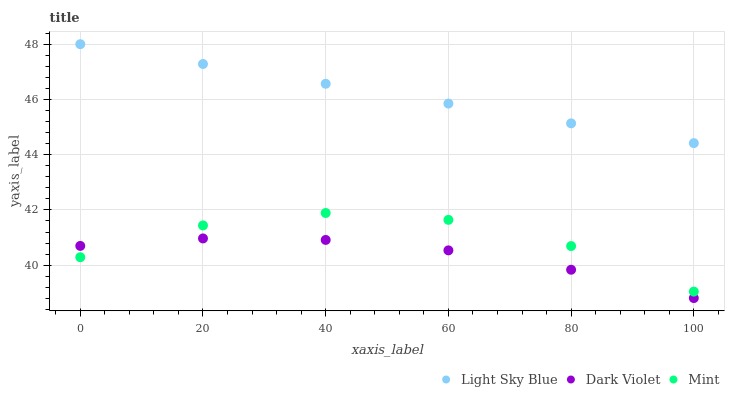Does Dark Violet have the minimum area under the curve?
Answer yes or no. Yes. Does Light Sky Blue have the maximum area under the curve?
Answer yes or no. Yes. Does Mint have the minimum area under the curve?
Answer yes or no. No. Does Mint have the maximum area under the curve?
Answer yes or no. No. Is Light Sky Blue the smoothest?
Answer yes or no. Yes. Is Mint the roughest?
Answer yes or no. Yes. Is Dark Violet the smoothest?
Answer yes or no. No. Is Dark Violet the roughest?
Answer yes or no. No. Does Dark Violet have the lowest value?
Answer yes or no. Yes. Does Mint have the lowest value?
Answer yes or no. No. Does Light Sky Blue have the highest value?
Answer yes or no. Yes. Does Mint have the highest value?
Answer yes or no. No. Is Mint less than Light Sky Blue?
Answer yes or no. Yes. Is Light Sky Blue greater than Mint?
Answer yes or no. Yes. Does Dark Violet intersect Mint?
Answer yes or no. Yes. Is Dark Violet less than Mint?
Answer yes or no. No. Is Dark Violet greater than Mint?
Answer yes or no. No. Does Mint intersect Light Sky Blue?
Answer yes or no. No. 